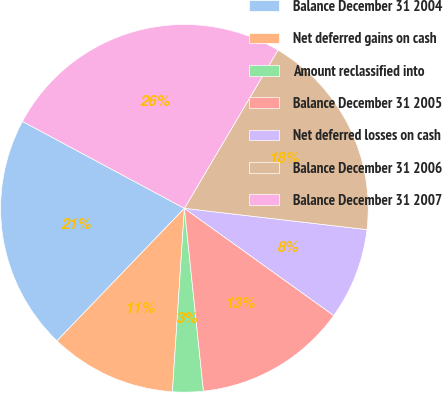<chart> <loc_0><loc_0><loc_500><loc_500><pie_chart><fcel>Balance December 31 2004<fcel>Net deferred gains on cash<fcel>Amount reclassified into<fcel>Balance December 31 2005<fcel>Net deferred losses on cash<fcel>Balance December 31 2006<fcel>Balance December 31 2007<nl><fcel>20.65%<fcel>11.15%<fcel>2.69%<fcel>13.44%<fcel>8.06%<fcel>18.35%<fcel>25.66%<nl></chart> 